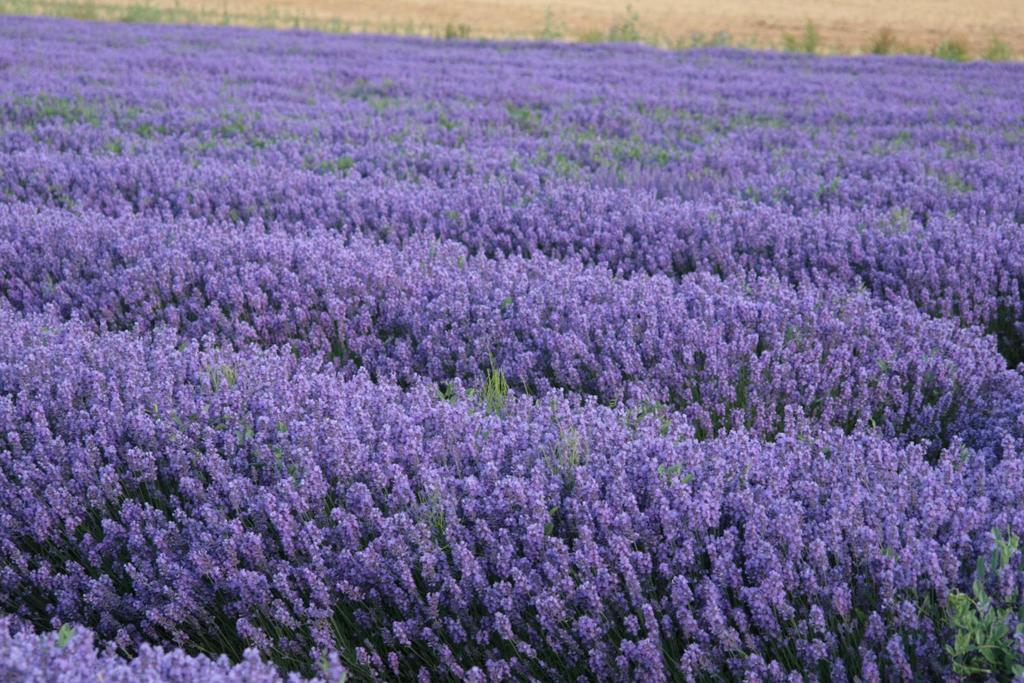What type of living organisms can be seen in the image? There is a group of plants in the image. What specific part of the plants are visible in the image? There are flowers in the image. What is visible at the top of the image? The ground is visible at the top of the image. What type of comb can be seen in the image? There is no comb present in the image. How does the button on the plant look in the image? There is no button on the plants in the image. 